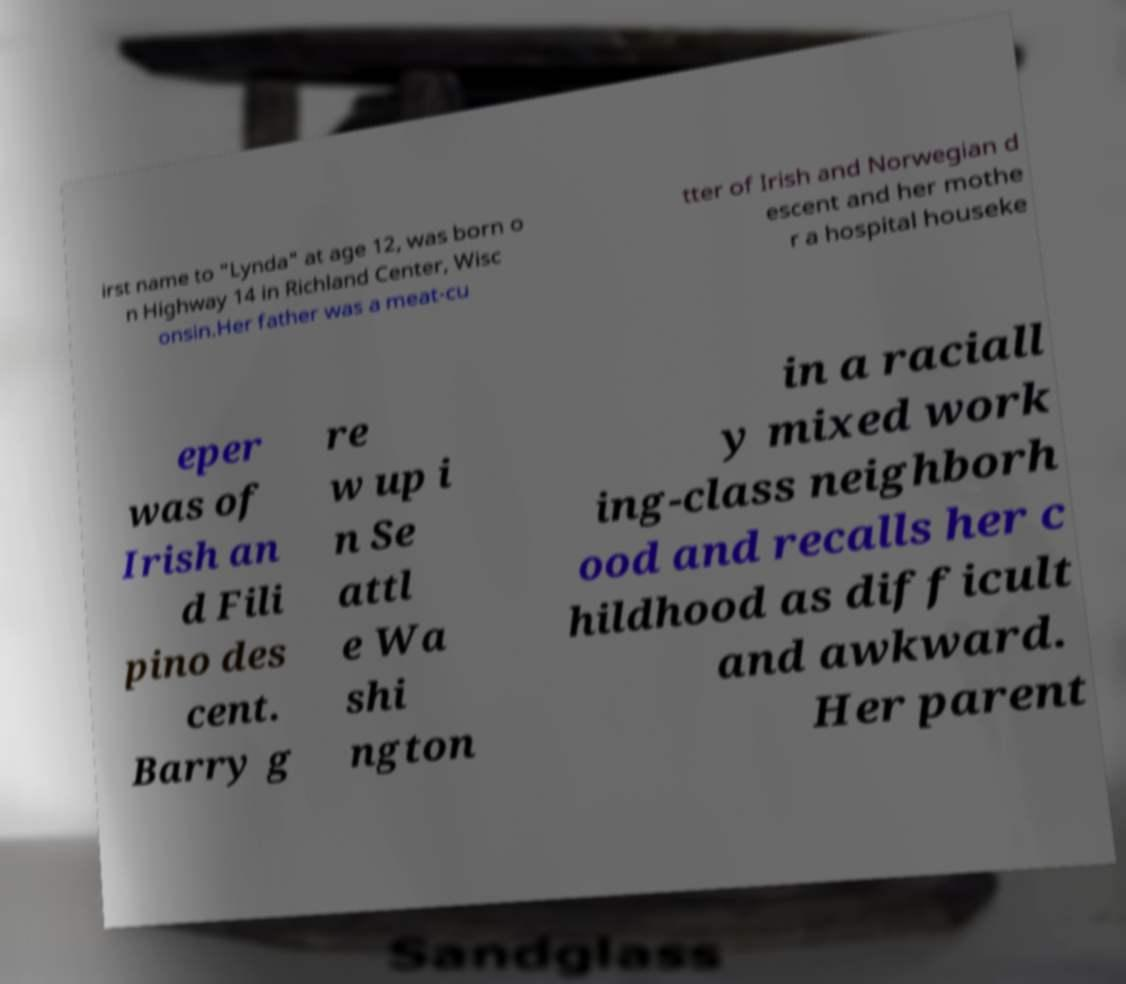Could you extract and type out the text from this image? irst name to "Lynda" at age 12, was born o n Highway 14 in Richland Center, Wisc onsin.Her father was a meat-cu tter of Irish and Norwegian d escent and her mothe r a hospital houseke eper was of Irish an d Fili pino des cent. Barry g re w up i n Se attl e Wa shi ngton in a raciall y mixed work ing-class neighborh ood and recalls her c hildhood as difficult and awkward. Her parent 